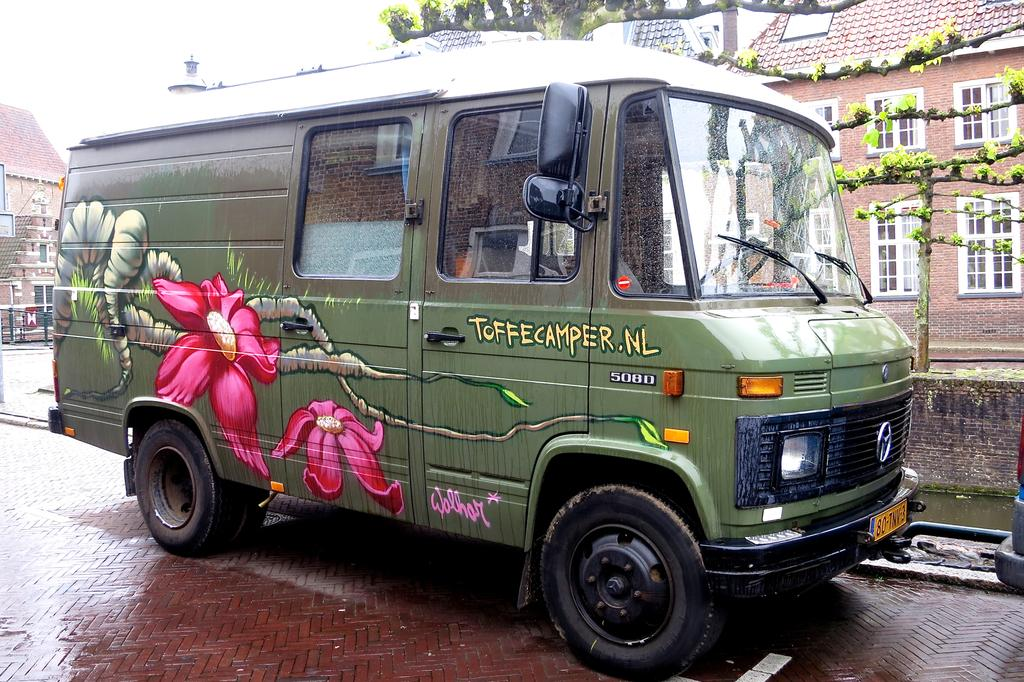<image>
Provide a brief description of the given image. toffecamper is written on the side of the van 